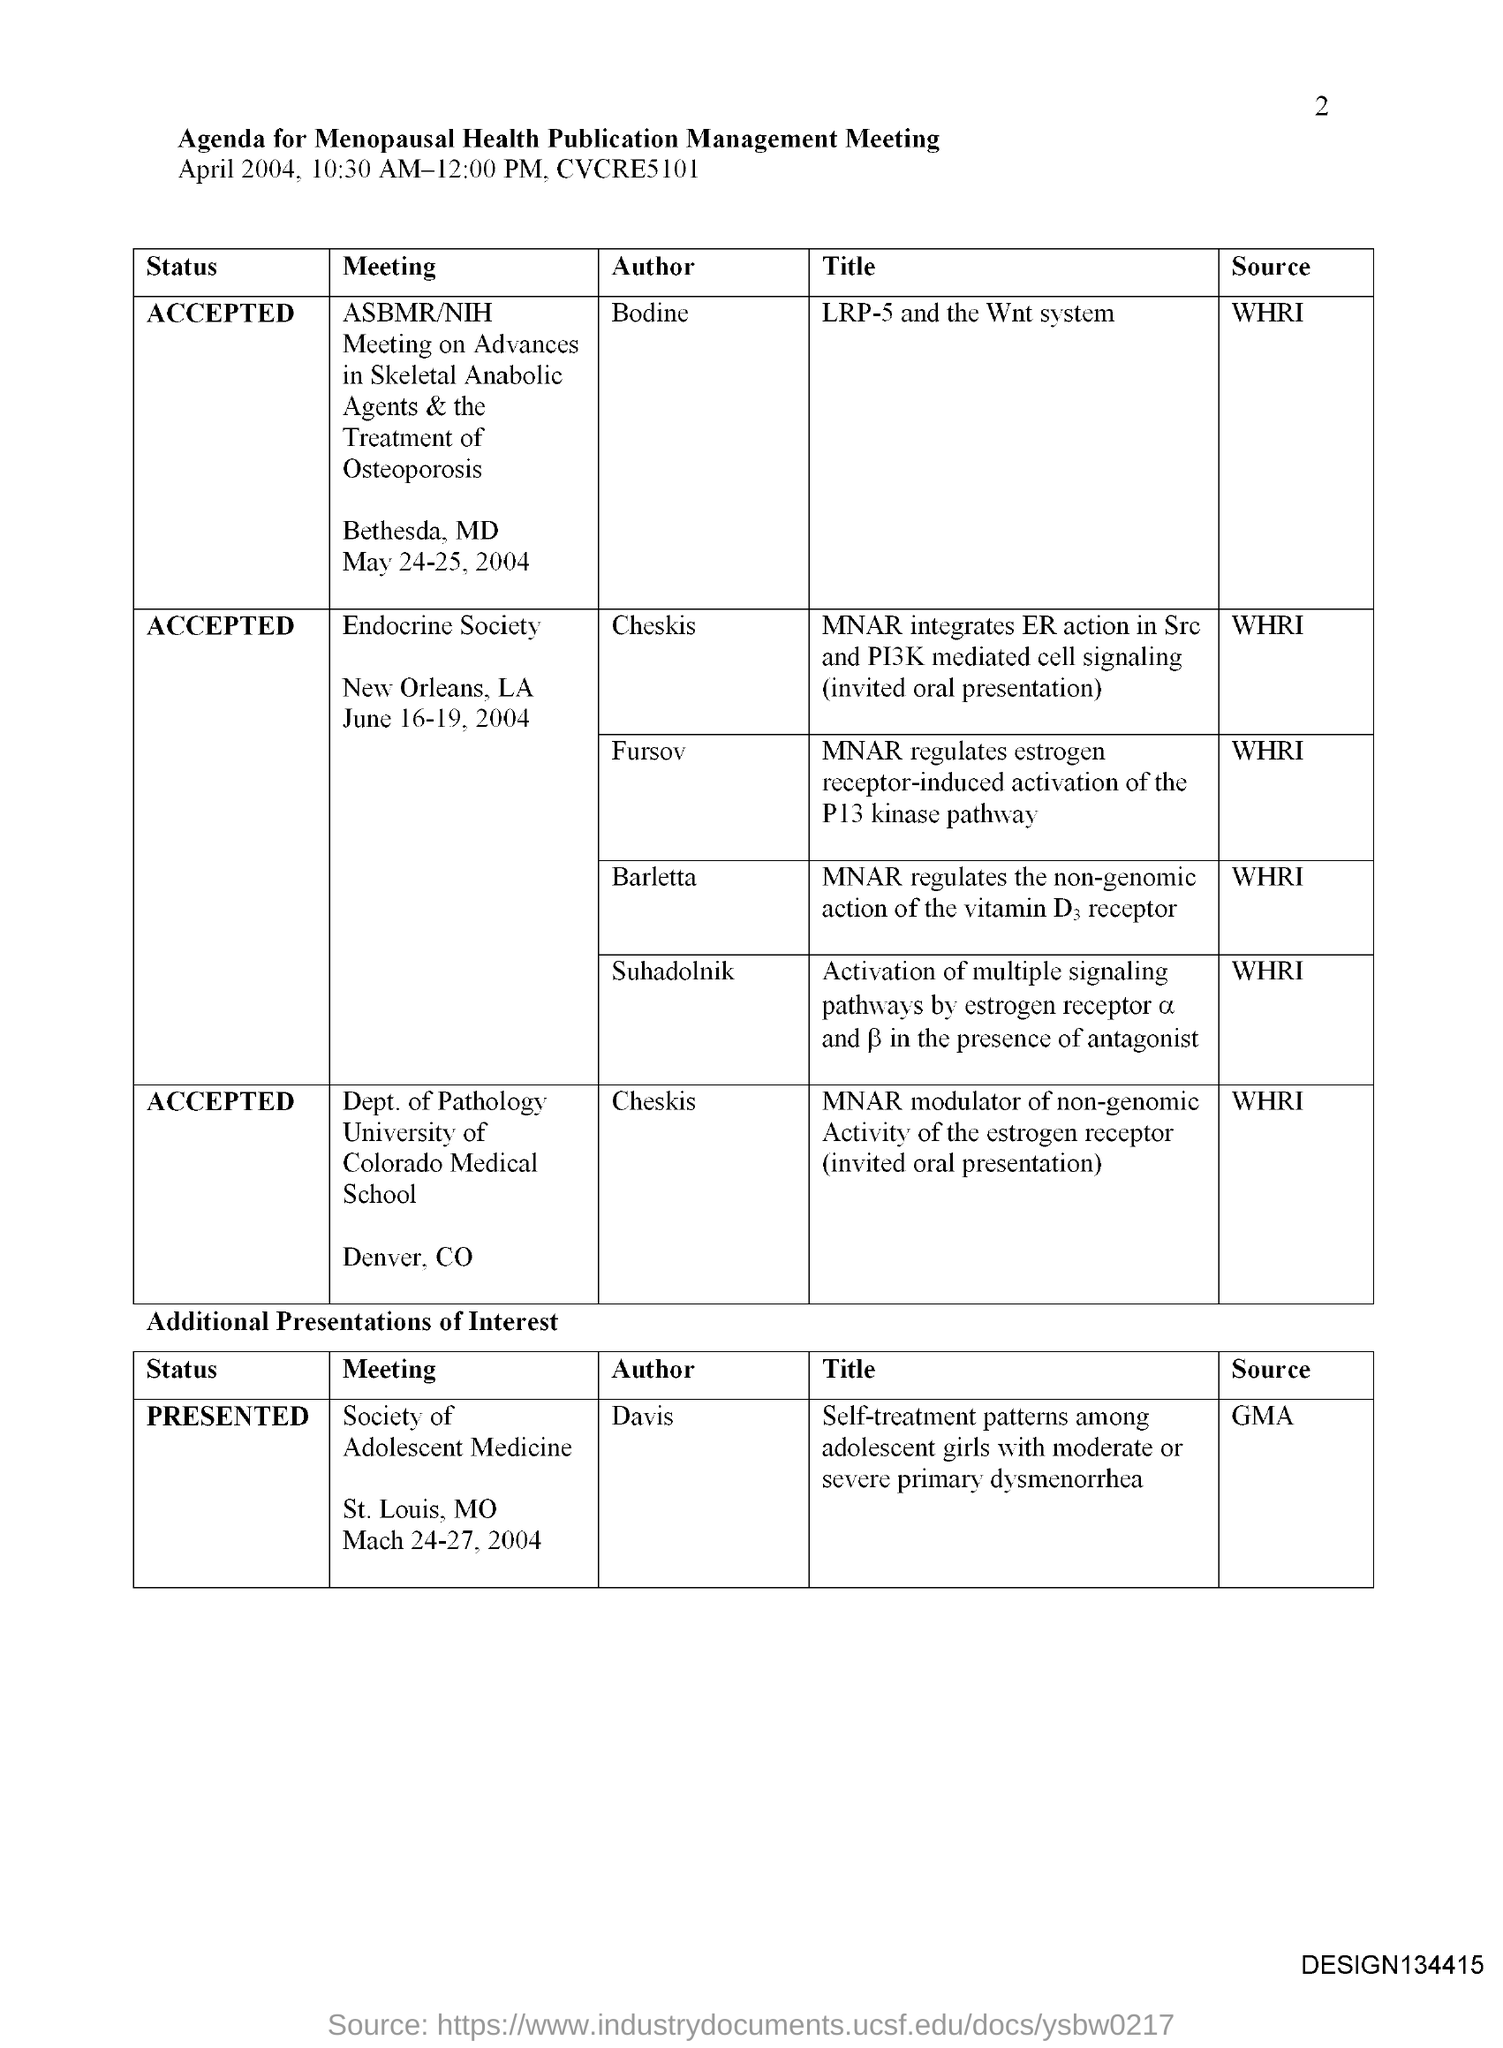Mention a couple of crucial points in this snapshot. The meeting society of adolescent medicine is authored by Davis. The page number is 2, as declared. 